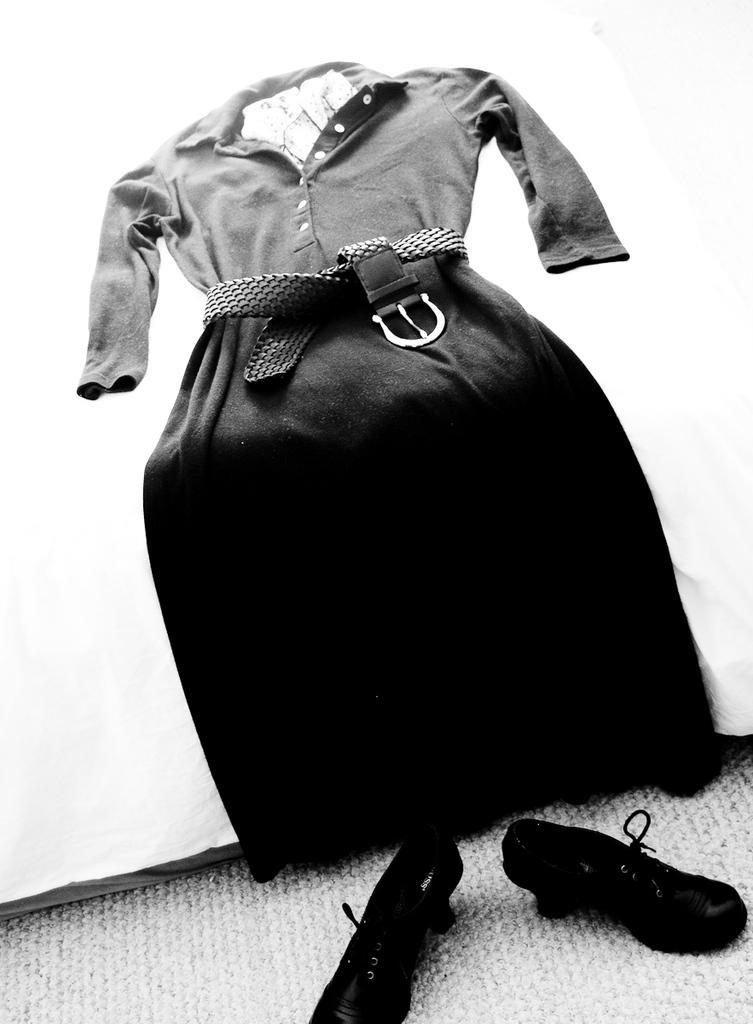Could you give a brief overview of what you see in this image? In this picture there is a cocktail dress in the center of the image and there are shoes at the bottom side of the image. 